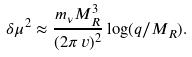<formula> <loc_0><loc_0><loc_500><loc_500>\delta \mu ^ { 2 } \approx \frac { m _ { \nu } M _ { R } ^ { 3 } } { ( 2 \pi \, v ) ^ { 2 } } \log ( q / M _ { R } ) .</formula> 